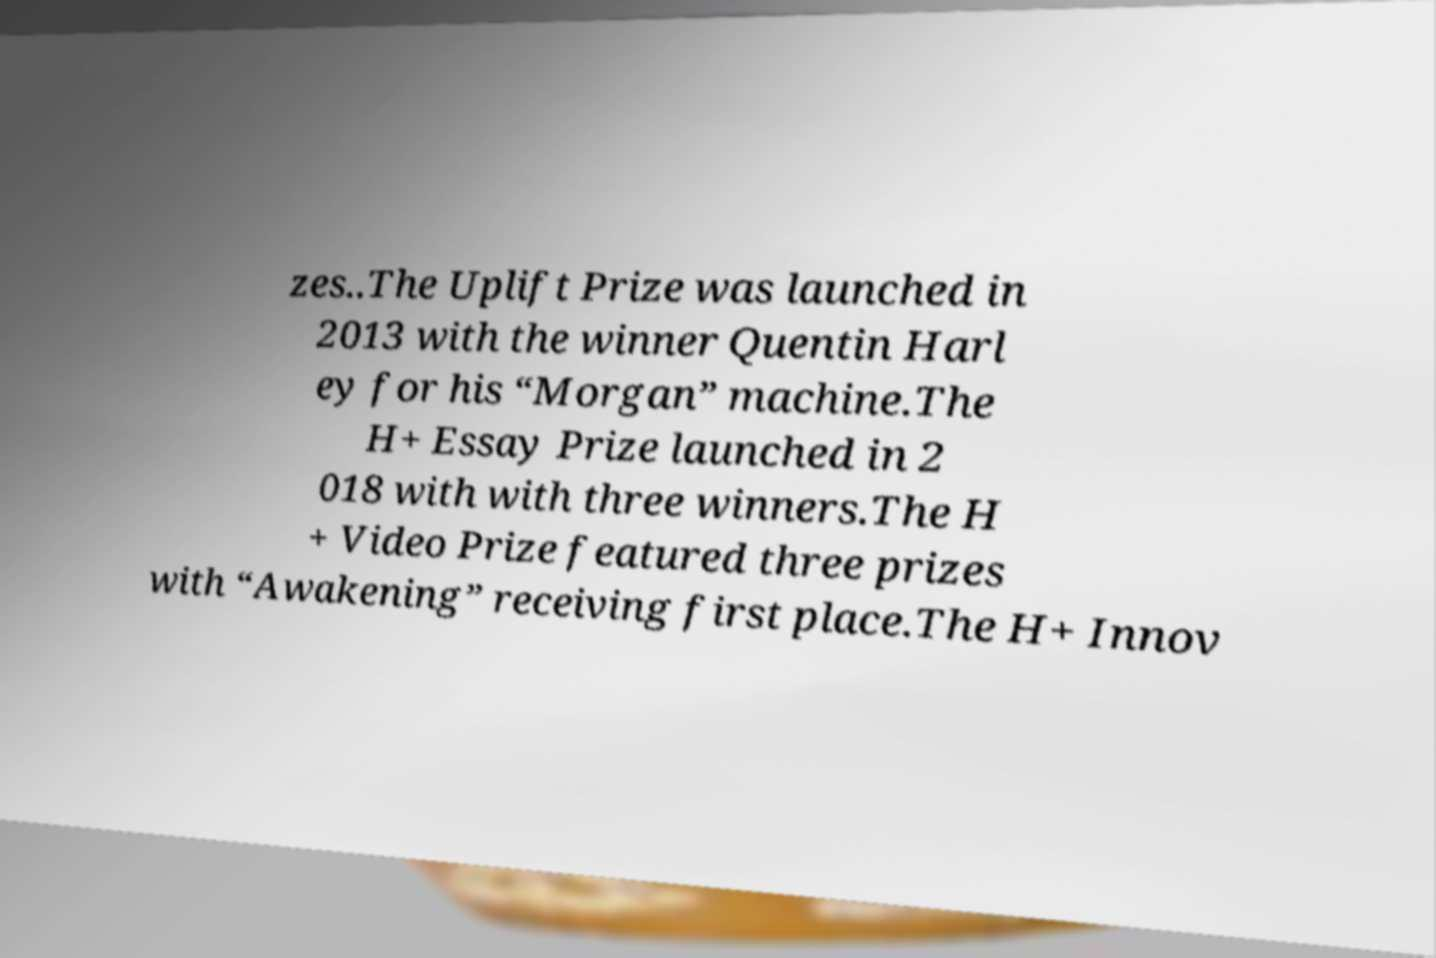I need the written content from this picture converted into text. Can you do that? zes..The Uplift Prize was launched in 2013 with the winner Quentin Harl ey for his “Morgan” machine.The H+ Essay Prize launched in 2 018 with with three winners.The H + Video Prize featured three prizes with “Awakening” receiving first place.The H+ Innov 